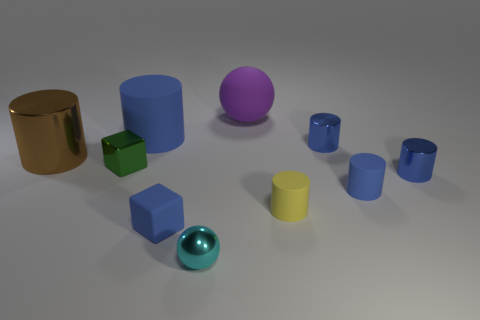How many blue cylinders must be subtracted to get 1 blue cylinders? 3 Subtract all tiny blue metallic cylinders. How many cylinders are left? 4 Subtract 1 blocks. How many blocks are left? 1 Subtract all brown cylinders. How many cylinders are left? 5 Subtract all balls. How many objects are left? 8 Subtract all yellow balls. How many blue cylinders are left? 4 Add 6 tiny rubber blocks. How many tiny rubber blocks are left? 7 Add 7 small blue rubber cylinders. How many small blue rubber cylinders exist? 8 Subtract 0 gray balls. How many objects are left? 10 Subtract all brown spheres. Subtract all cyan blocks. How many spheres are left? 2 